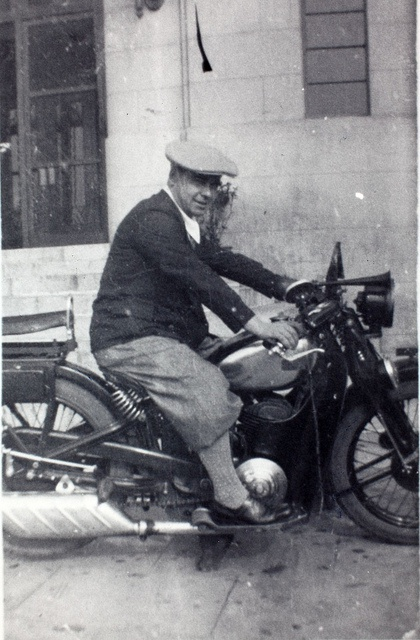Describe the objects in this image and their specific colors. I can see motorcycle in gray, black, darkgray, and lightgray tones and people in gray, black, and darkgray tones in this image. 